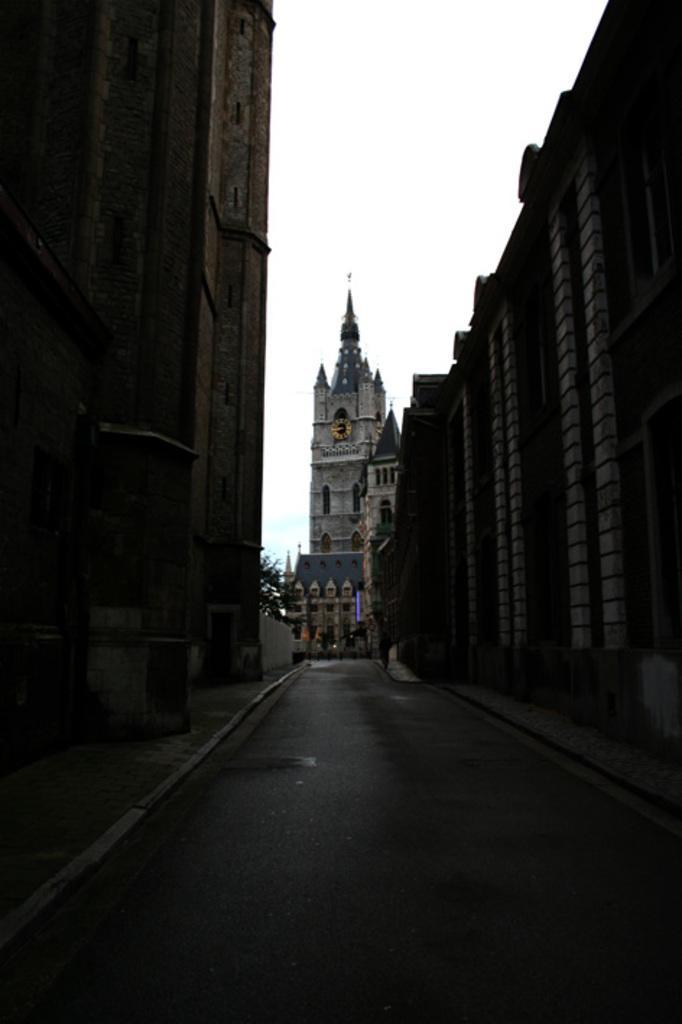Could you give a brief overview of what you see in this image? In the image there is a road and on the either side of the road there are tall buildings and in front of the road there is a huge tower and in the middle of the tower there is a clock. In the background there is a sky. 